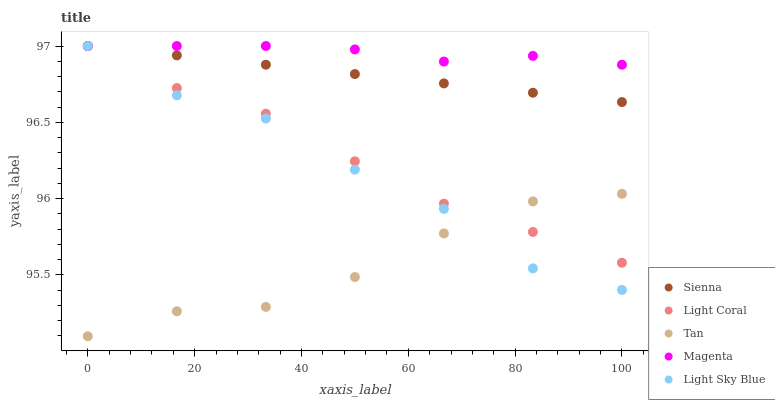Does Tan have the minimum area under the curve?
Answer yes or no. Yes. Does Magenta have the maximum area under the curve?
Answer yes or no. Yes. Does Light Coral have the minimum area under the curve?
Answer yes or no. No. Does Light Coral have the maximum area under the curve?
Answer yes or no. No. Is Sienna the smoothest?
Answer yes or no. Yes. Is Light Sky Blue the roughest?
Answer yes or no. Yes. Is Light Coral the smoothest?
Answer yes or no. No. Is Light Coral the roughest?
Answer yes or no. No. Does Tan have the lowest value?
Answer yes or no. Yes. Does Light Coral have the lowest value?
Answer yes or no. No. Does Magenta have the highest value?
Answer yes or no. Yes. Does Tan have the highest value?
Answer yes or no. No. Is Tan less than Magenta?
Answer yes or no. Yes. Is Sienna greater than Tan?
Answer yes or no. Yes. Does Sienna intersect Light Sky Blue?
Answer yes or no. Yes. Is Sienna less than Light Sky Blue?
Answer yes or no. No. Is Sienna greater than Light Sky Blue?
Answer yes or no. No. Does Tan intersect Magenta?
Answer yes or no. No. 